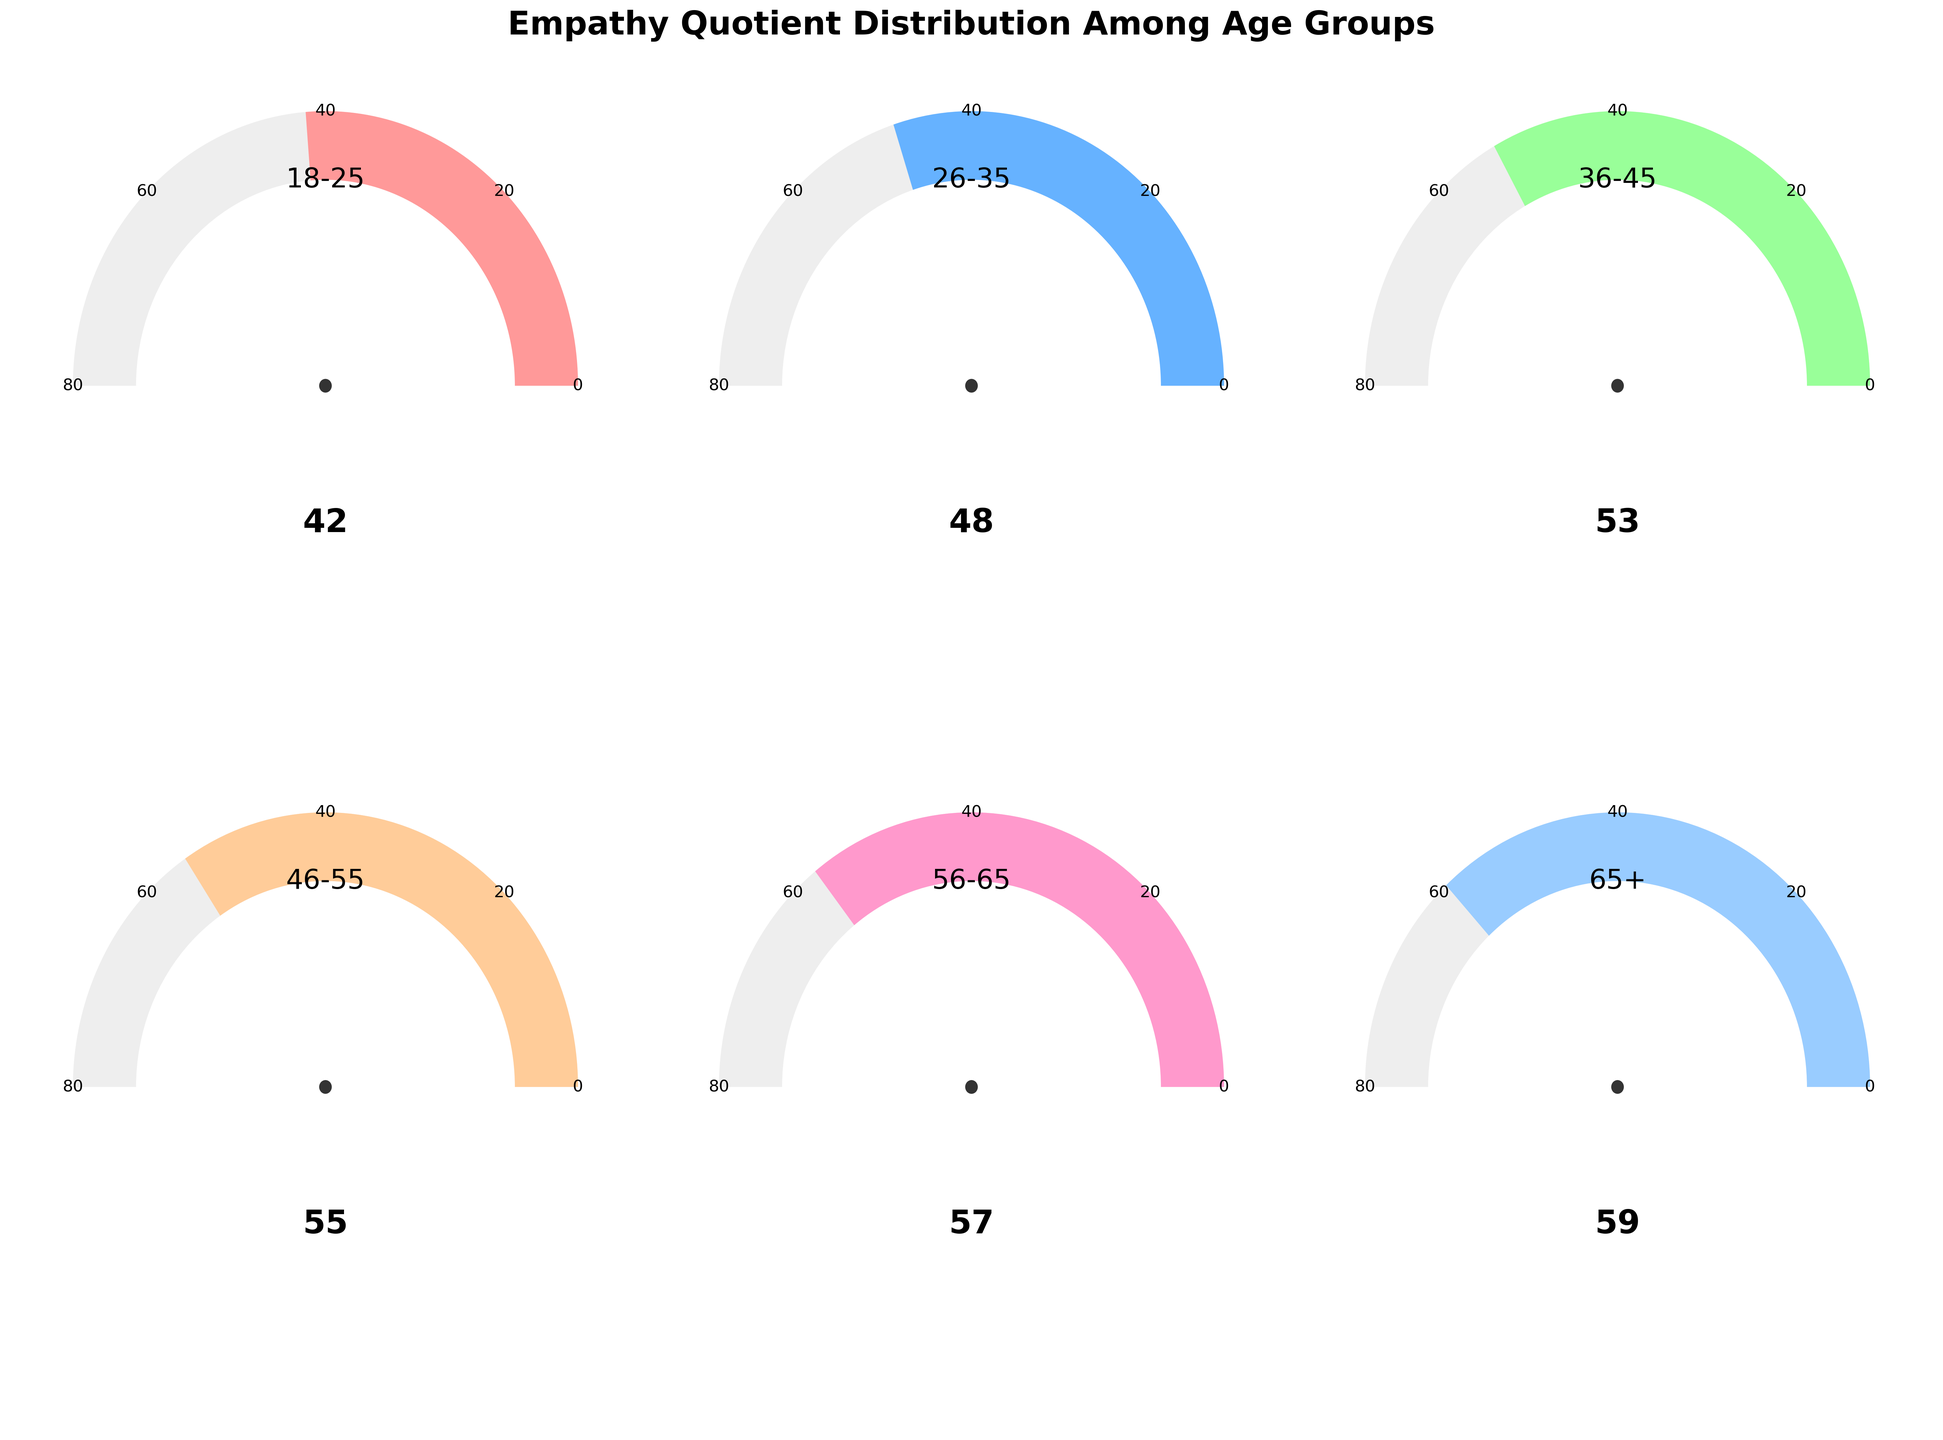What is the empathy quotient for the 18-25 age group? The gauge chart for the 18-25 age group shows an empathy quotient value.
Answer: 42 What age group has the highest empathy quotient? By looking at the gauge charts for all age groups, the highest value is found in the 65+ age group.
Answer: 65+ How does the empathy quotient change from the 18-25 age group to the 26-35 age group? The empathy quotient for the 18-25 age group is 42, and for the 26-35 age group, it is 48.
Answer: Increases by 6 Which age group has an empathy quotient closest to 50? The gauge chart for the 26-35 age group shows an empathy quotient value of 48, which is the closest to 50 among all age groups.
Answer: 26-35 What is the range of the empathy quotient values displayed in the gauge charts? The lowest empathy quotient is 42 (18-25 age group), and the highest is 59 (65+ age group). The range is calculated as 59 - 42.
Answer: 17 What is the average empathy quotient across all age groups? The values given are 42, 48, 53, 55, 57, and 59. Summing them up gives 314. Dividing by the number of age groups (6) gives 314/6.
Answer: 52.33 Which age group shows a near midpoint (median) empathy quotient in these six groups? When the empathy quotients are ordered (42, 48, 53, 55, 57, 59), the median value is the average of the 3rd and 4th values (53 and 55). The 36-45 and 46-55 age groups show these values.
Answer: 36-45 and 46-55 How many age groups have an empathy quotient higher than 50? From the gauge charts, the empathy quotients higher than 50 are for the 36-45, 46-55, 56-65, and 65+ age groups.
Answer: 4 What is the visual angle corresponding to the empathy quotient of 48? The gauge angle is calculated as the proportion of the empathy quotient relative to the full range (0 to 80). For 48, this is (48/80) * 180 degrees.
Answer: 108 degrees 